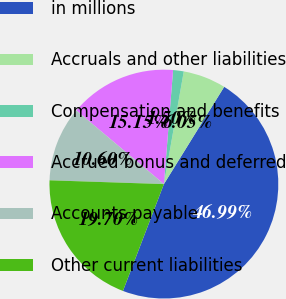<chart> <loc_0><loc_0><loc_500><loc_500><pie_chart><fcel>in millions<fcel>Accruals and other liabilities<fcel>Compensation and benefits<fcel>Accrued bonus and deferred<fcel>Accounts payable<fcel>Other current liabilities<nl><fcel>46.99%<fcel>6.05%<fcel>1.5%<fcel>15.15%<fcel>10.6%<fcel>19.7%<nl></chart> 